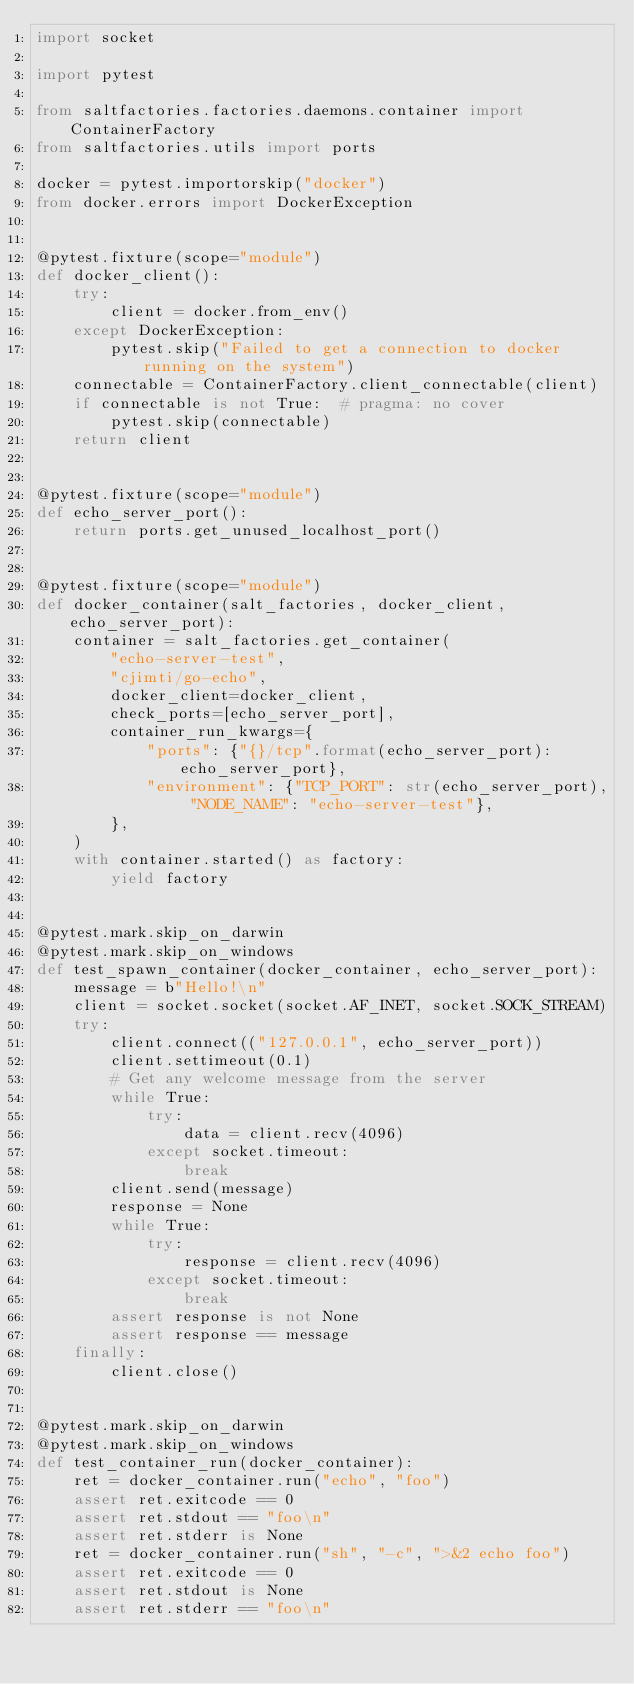<code> <loc_0><loc_0><loc_500><loc_500><_Python_>import socket

import pytest

from saltfactories.factories.daemons.container import ContainerFactory
from saltfactories.utils import ports

docker = pytest.importorskip("docker")
from docker.errors import DockerException


@pytest.fixture(scope="module")
def docker_client():
    try:
        client = docker.from_env()
    except DockerException:
        pytest.skip("Failed to get a connection to docker running on the system")
    connectable = ContainerFactory.client_connectable(client)
    if connectable is not True:  # pragma: no cover
        pytest.skip(connectable)
    return client


@pytest.fixture(scope="module")
def echo_server_port():
    return ports.get_unused_localhost_port()


@pytest.fixture(scope="module")
def docker_container(salt_factories, docker_client, echo_server_port):
    container = salt_factories.get_container(
        "echo-server-test",
        "cjimti/go-echo",
        docker_client=docker_client,
        check_ports=[echo_server_port],
        container_run_kwargs={
            "ports": {"{}/tcp".format(echo_server_port): echo_server_port},
            "environment": {"TCP_PORT": str(echo_server_port), "NODE_NAME": "echo-server-test"},
        },
    )
    with container.started() as factory:
        yield factory


@pytest.mark.skip_on_darwin
@pytest.mark.skip_on_windows
def test_spawn_container(docker_container, echo_server_port):
    message = b"Hello!\n"
    client = socket.socket(socket.AF_INET, socket.SOCK_STREAM)
    try:
        client.connect(("127.0.0.1", echo_server_port))
        client.settimeout(0.1)
        # Get any welcome message from the server
        while True:
            try:
                data = client.recv(4096)
            except socket.timeout:
                break
        client.send(message)
        response = None
        while True:
            try:
                response = client.recv(4096)
            except socket.timeout:
                break
        assert response is not None
        assert response == message
    finally:
        client.close()


@pytest.mark.skip_on_darwin
@pytest.mark.skip_on_windows
def test_container_run(docker_container):
    ret = docker_container.run("echo", "foo")
    assert ret.exitcode == 0
    assert ret.stdout == "foo\n"
    assert ret.stderr is None
    ret = docker_container.run("sh", "-c", ">&2 echo foo")
    assert ret.exitcode == 0
    assert ret.stdout is None
    assert ret.stderr == "foo\n"
</code> 